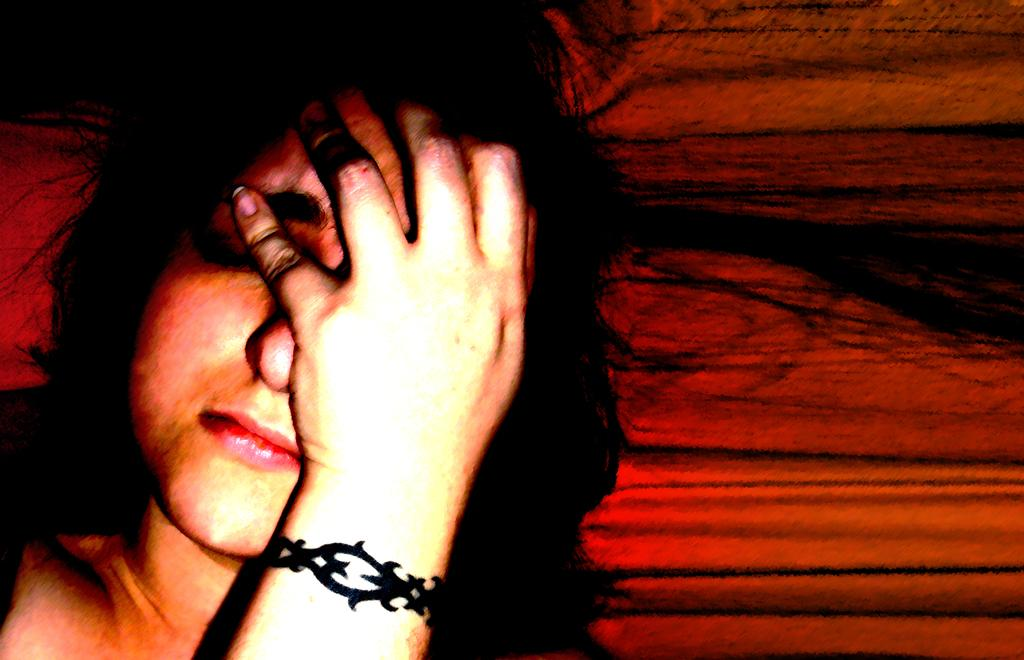What is the main subject of the image? There is a person in the image. Can you describe the background of the image? The background of the image has red and black colors. What type of twig is the person holding in the image? There is no twig present in the image. What is the person attempting to do in the image? The image does not provide enough information to determine what the person might be attempting to do. 